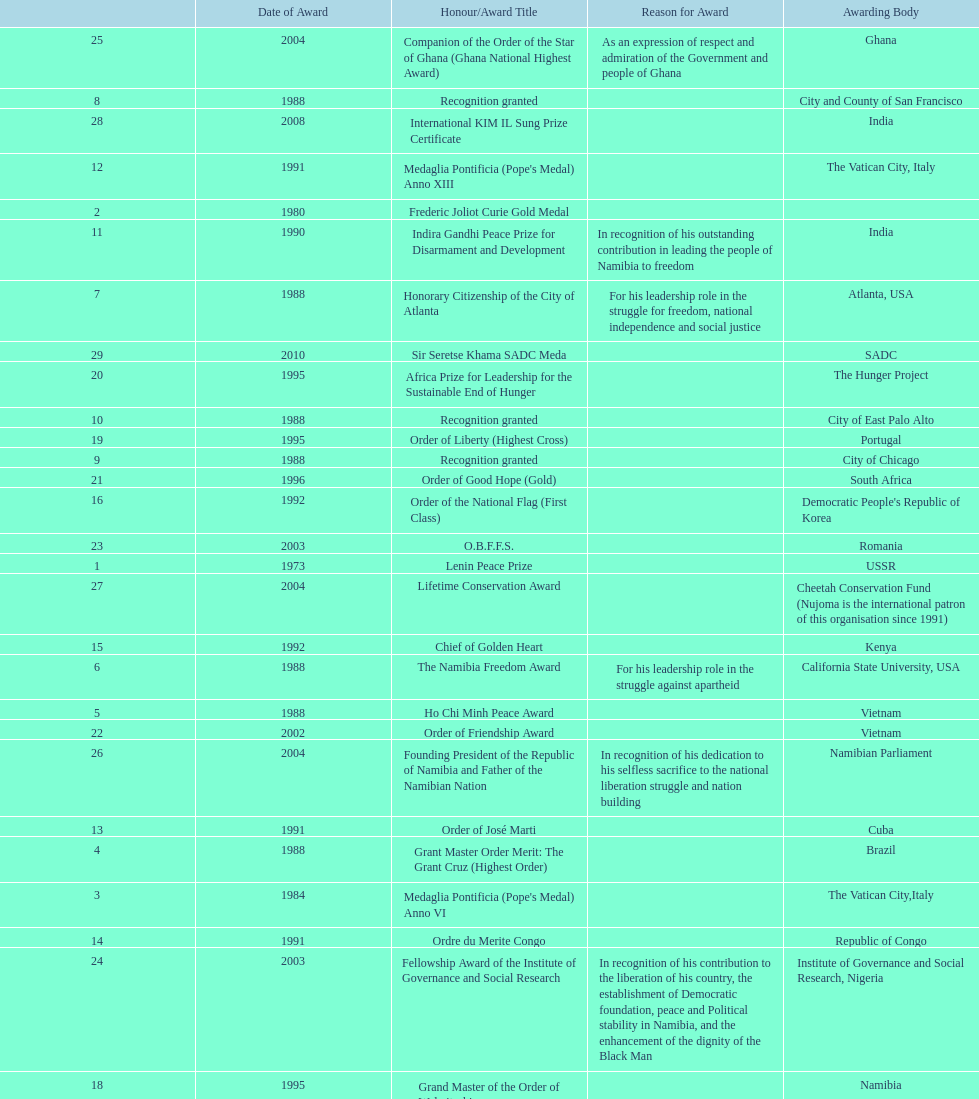What award was won previously just before the medaglia pontificia anno xiii was awarded? Indira Gandhi Peace Prize for Disarmament and Development. 